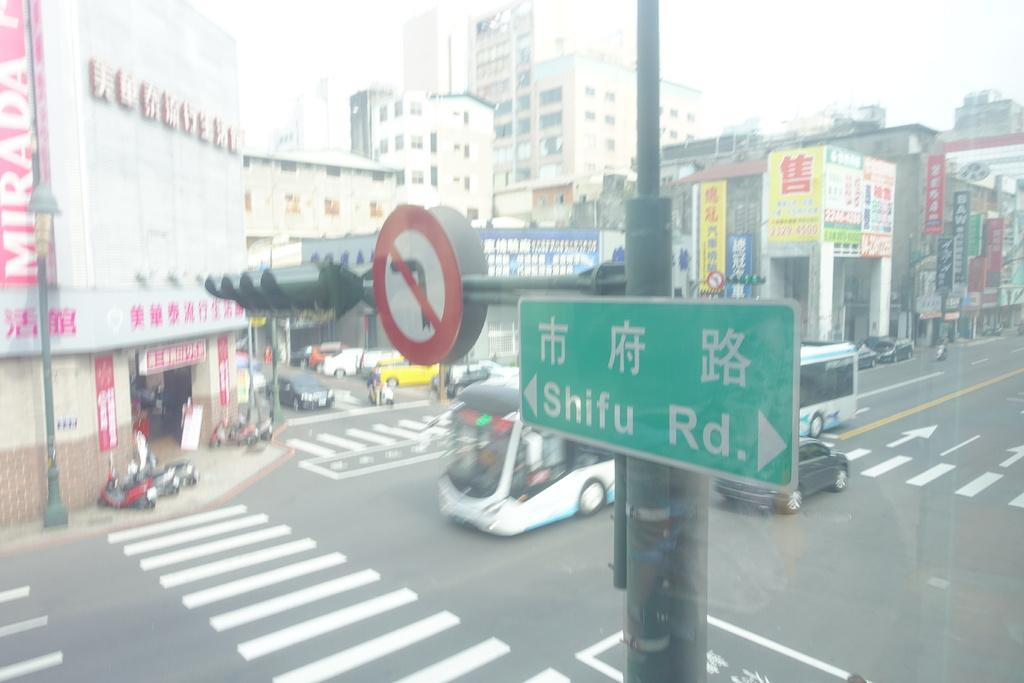Provide a one-sentence caption for the provided image. a cross section of the street at the intersection of Shifu Rd. 